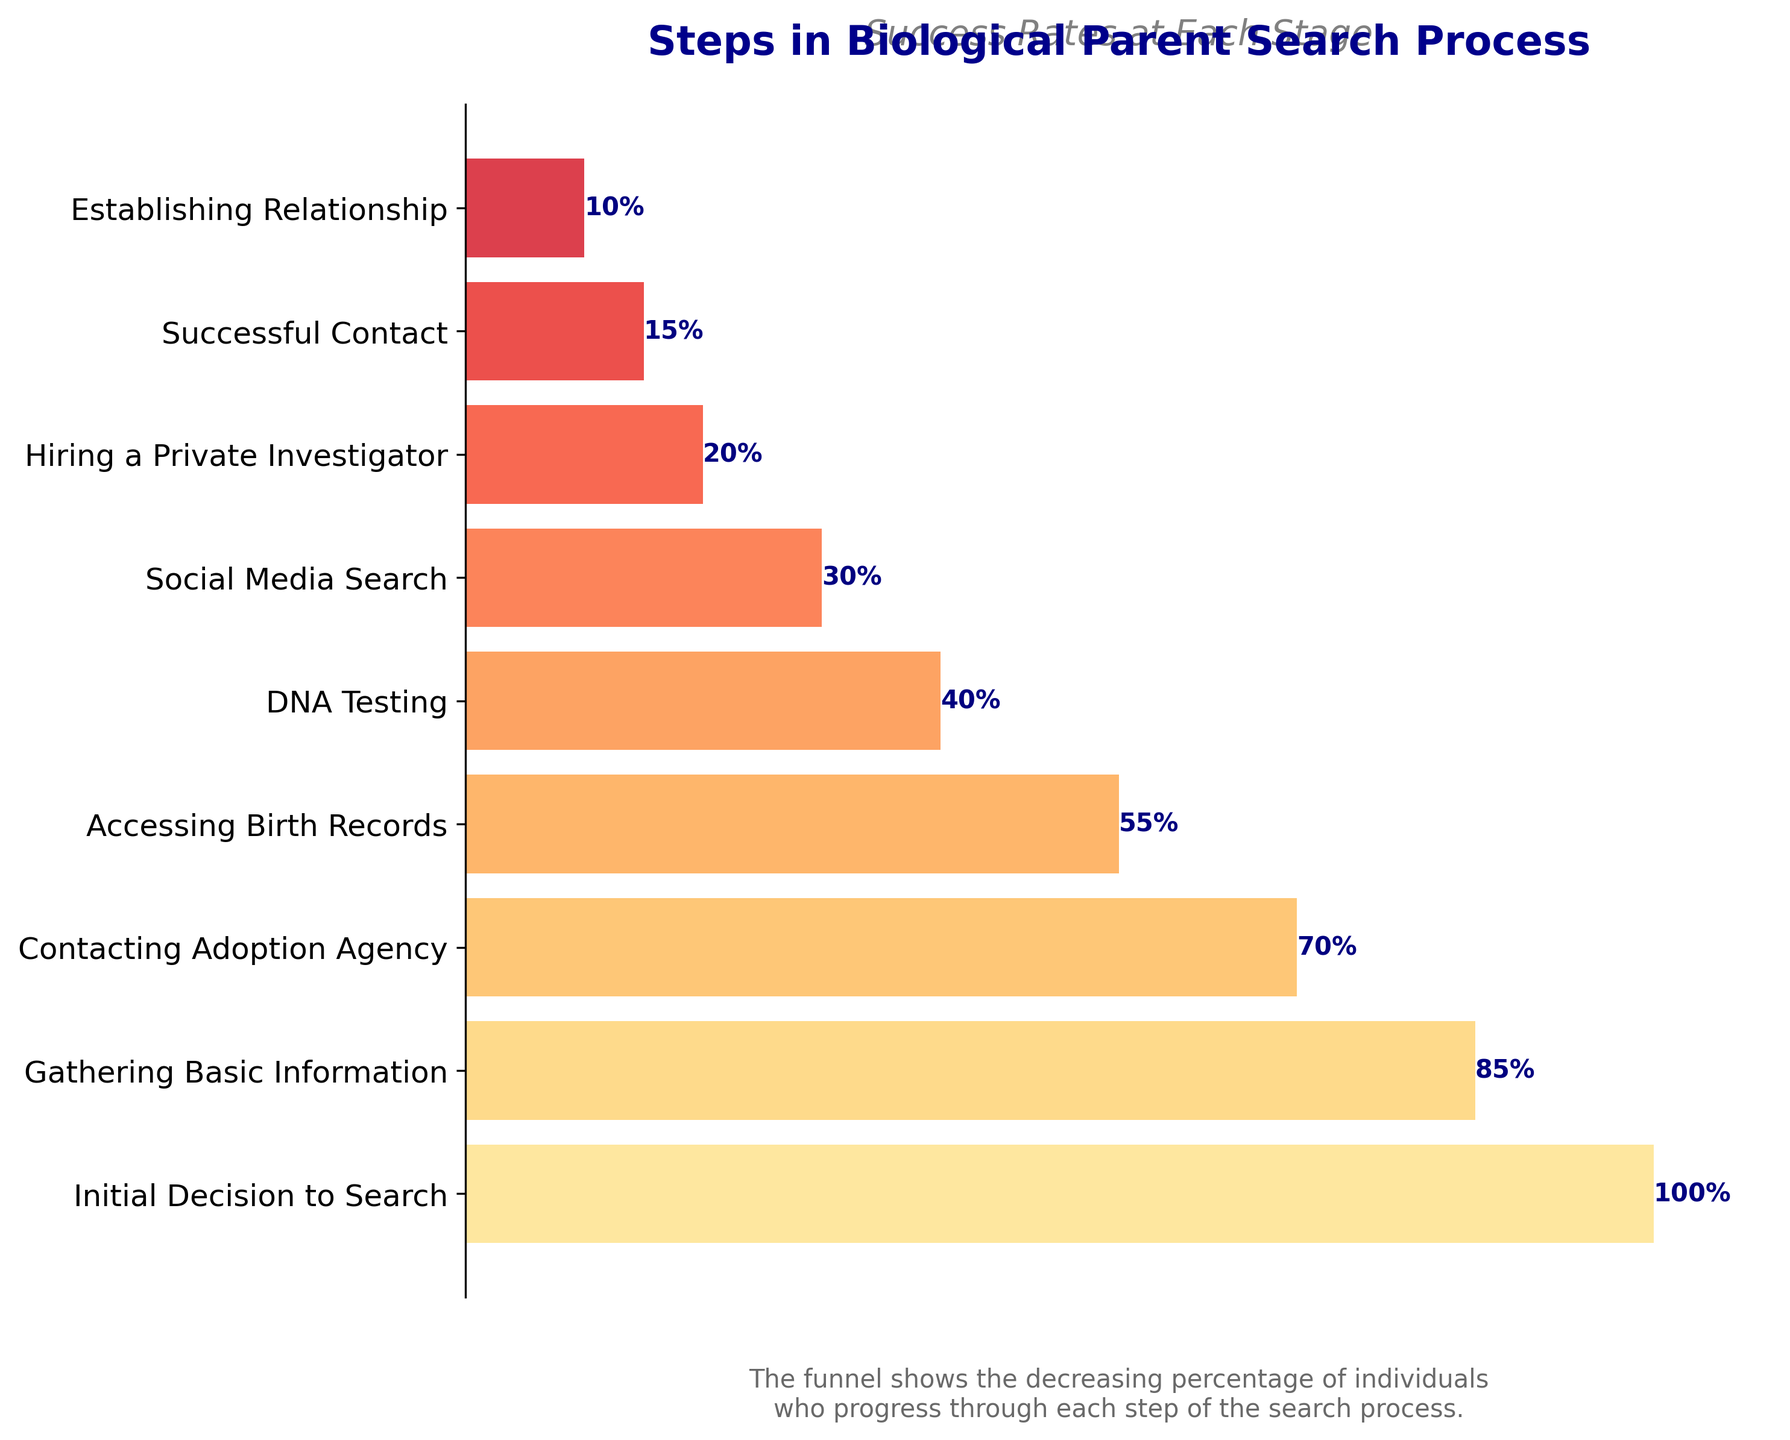What is the title of the chart? The title of the chart is located at the top and provides a summary of the figure's content in a concise manner.
Answer: Steps in Biological Parent Search Process How many steps are shown in the search process? The funnel chart visually presents the steps on the y-axis, with each step corresponding to a labeled bar. Count these labels to determine the total number of steps.
Answer: 9 What is the percentage of people who succeed in establishing a relationship with their biological parents? Look at the step labeled "Establishing Relationship" and find the corresponding percentage value on the bar.
Answer: 10% Which step has the greatest drop in success rate compared to the previous step? To determine the largest drop, calculate the difference in percentages between each consecutive step and identify the pair with the maximum negative difference. The steps are: 85 - 70 = 15%, 70 - 55 = 15%, 55 - 40 = 15%, 40 - 30 = 10%, 30 - 20 = 10%, 20 - 15 = 5%, 15 - 10 = 5%. The biggest drop is among the first three calculated, but they all show the same drop.
Answer: Three steps (Gathering Basic Information to Contacting Adoption Agency, Contacting Adoption Agency to Accessing Birth Records, Accessing Birth Records to DNA Testing) Between which two steps is the percentage drop the smallest? Compare the differences between each step, as calculated before, and identify the smallest drop. As shown: 85 - 70 = 15%, 70 - 55 = 15%, 55 - 40 = 15%, 40 - 30 = 10%, 30 - 20 = 10%, 20 - 15 = 5%, 15 - 10 = 5%. The smallest drop is seen in the last two differences.
Answer: Hiring a Private Investigator to Successful Contact and Successful Contact to Establishing Relationship What is the percentage of individuals who gather basic information? Locate the step labeled "Gathering Basic Information" and note the associated percentage.
Answer: 85% How does the success rate of contacting the adoption agency compare to that of accessing birth records? Find the percentages for "Contacting Adoption Agency" and "Accessing Birth Records" and determine which is higher or lower. Contacting Adoption Agency has 70% and Accessing Birth Records has 55%.
Answer: Contacting Adoption Agency (70%) is higher than Accessing Birth Records (55%) What's the average success rate across all steps given? Sum all the percentage values and divide by the number of steps. (100 + 85 + 70 + 55 + 40 + 30 + 20 + 15 + 10) / 9 = 47.22%.
Answer: 47.22% What's the success rate for those who proceed with social media searches but not hiring a private investigator? The success rate for the social media search is the percentage corresponding to this step on the chart.
Answer: 30% 